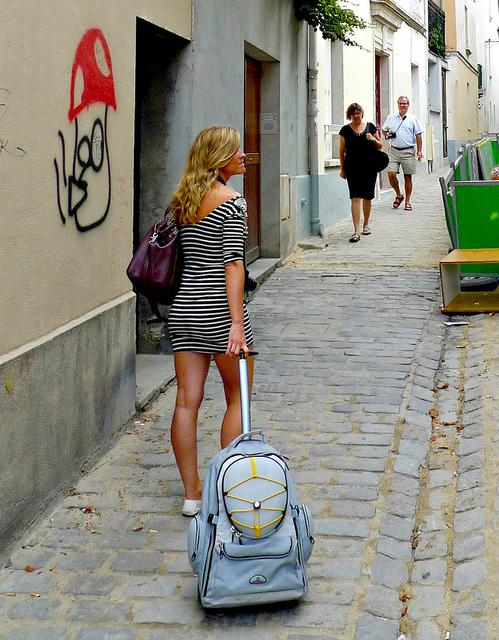Where might the lady on the sidewalk be going? hotel 